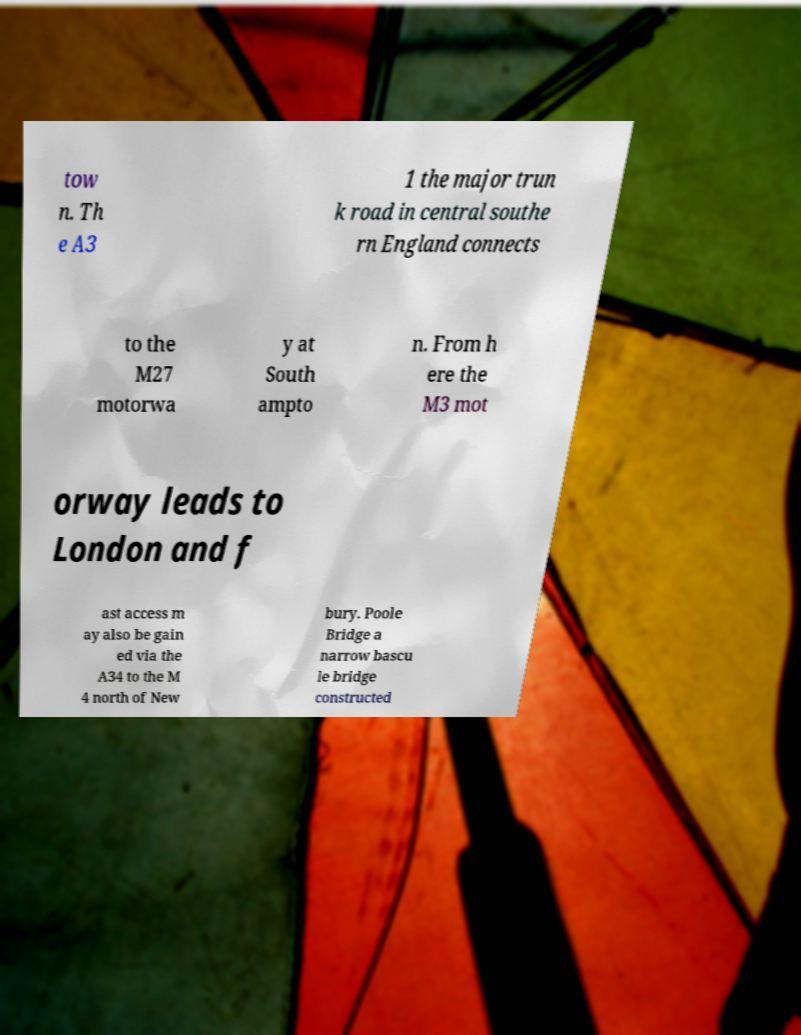I need the written content from this picture converted into text. Can you do that? tow n. Th e A3 1 the major trun k road in central southe rn England connects to the M27 motorwa y at South ampto n. From h ere the M3 mot orway leads to London and f ast access m ay also be gain ed via the A34 to the M 4 north of New bury. Poole Bridge a narrow bascu le bridge constructed 